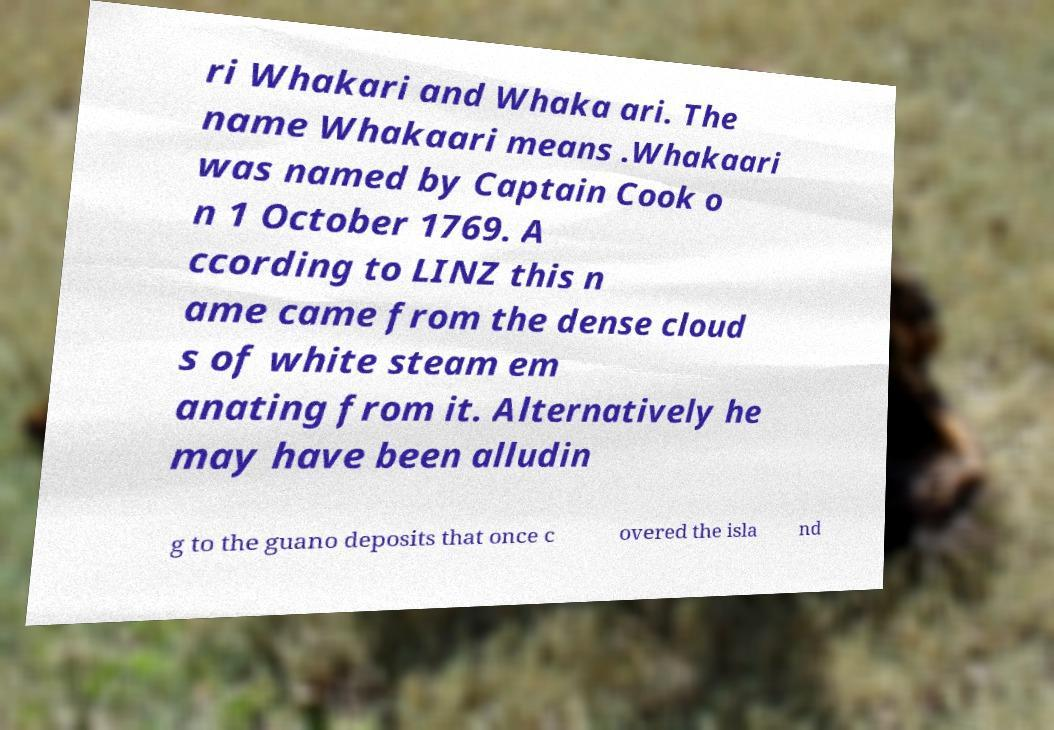Please read and relay the text visible in this image. What does it say? ri Whakari and Whaka ari. The name Whakaari means .Whakaari was named by Captain Cook o n 1 October 1769. A ccording to LINZ this n ame came from the dense cloud s of white steam em anating from it. Alternatively he may have been alludin g to the guano deposits that once c overed the isla nd 